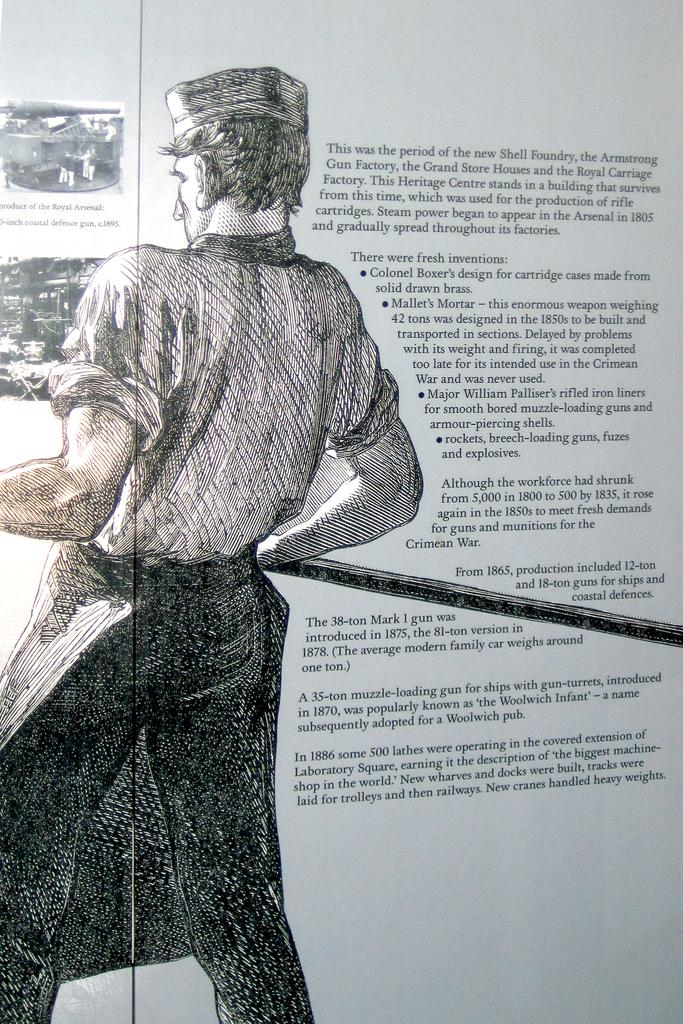Who is present in the image? There is a man in the image. What is the man holding in the image? The man is holding a stick. On which side of the image is the man located? The man is on the left side of the image. What can be seen on the right side of the image? There is text on the right side of the image. What type of spring is visible in the image? There is no spring present in the image. How does the man react to the shock in the image? There is no shock or reaction to a shock depicted in the image. 